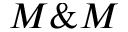<formula> <loc_0><loc_0><loc_500><loc_500>M \& M</formula> 